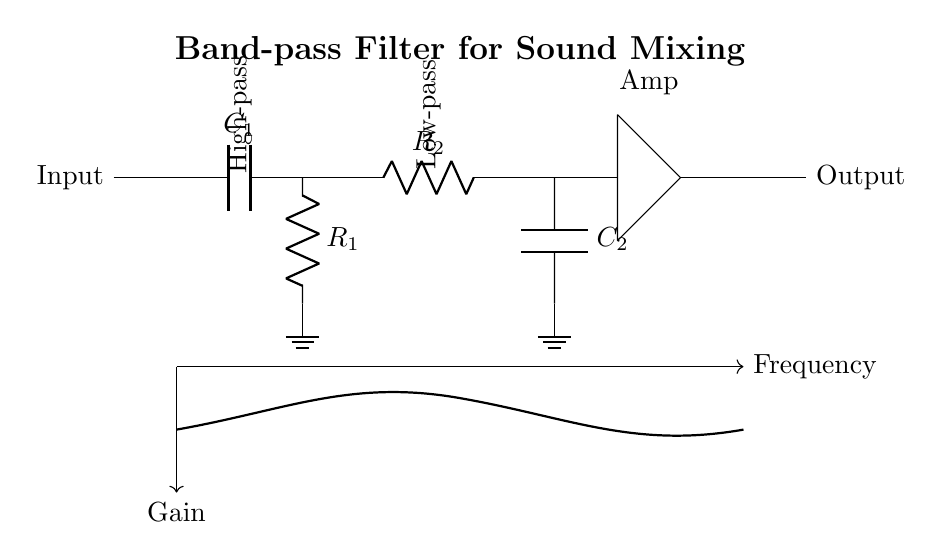What is the input of the circuit? The input of the circuit is labeled as "Input", indicating where the signal enters the circuit.
Answer: Input What is the first component in the high-pass filter section? The first component in the high-pass filter section is a capacitor, labeled as C1, which is responsible for allowing high frequency signals to pass while blocking low frequencies.
Answer: Capacitor What is the purpose of the amplifier in this circuit? The purpose of the amplifier, labeled as "Amp", is to increase the gain of the signal after it has passed through the filter sections, thereby enhancing the output signal.
Answer: Increase gain Which components form the low-pass filter section? The components that form the low-pass filter section are resistor R2 and capacitor C2, which together allow low frequency signals to pass while attenuating higher frequencies.
Answer: R2 and C2 What is the overall function of this circuit? The overall function of this circuit is to serve as a band-pass filter, allowing a specific range of frequencies to pass through while blocking others, making it useful for sound mixing applications.
Answer: Band-pass filter At which points does the gain response curve reach its peak? The gain response curve reaches its peaks around the cutoff frequencies determined by the capacitors and resistors in the configuration, specifically between the high-pass and low-pass filter sections.
Answer: Cutoff frequencies What does the frequency response graph indicate? The frequency response graph indicates how the gain of the filter varies with input frequency, showing regions of gain for desired frequencies and attenuation for others, typically with a band-pass characteristic.
Answer: Gain vs Frequency 